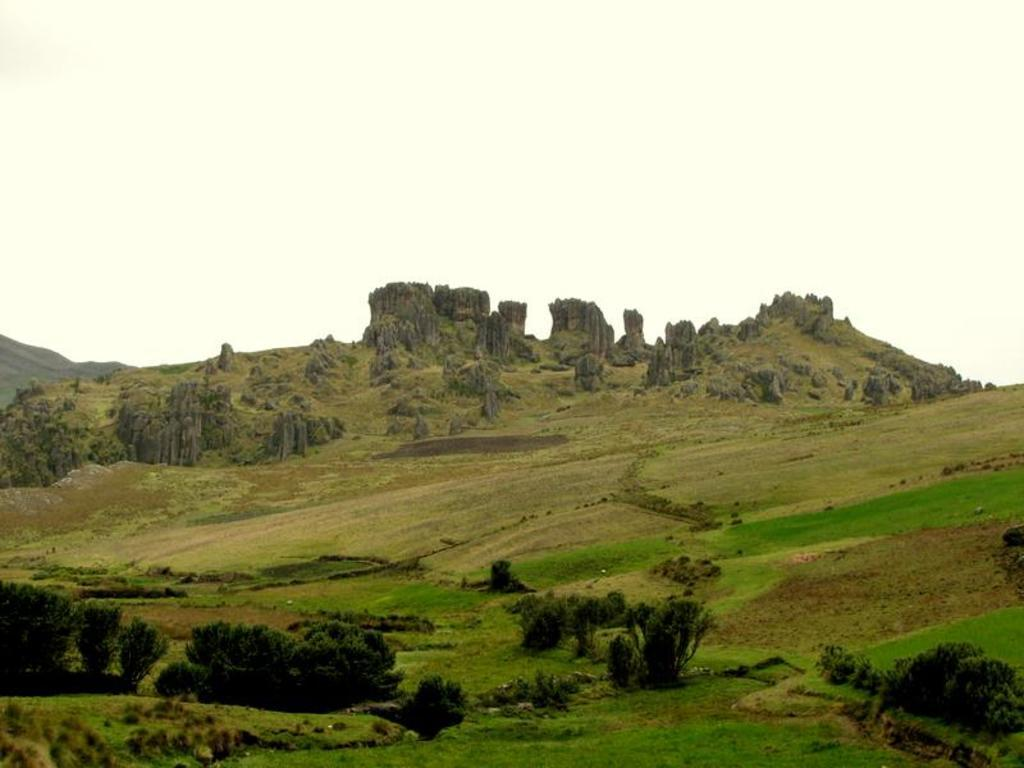What type of vegetation can be seen in the image? There are plants in the image. What is on the ground can be seen in the image? There is grass on the ground in the image. What is visible in the background of the image? There is a hill, rocks, and the sky visible in the background of the image. What type of light is being used to illuminate the plants in the image? There is no specific light source mentioned or visible in the image, so it cannot be determined what type of light is being used. 